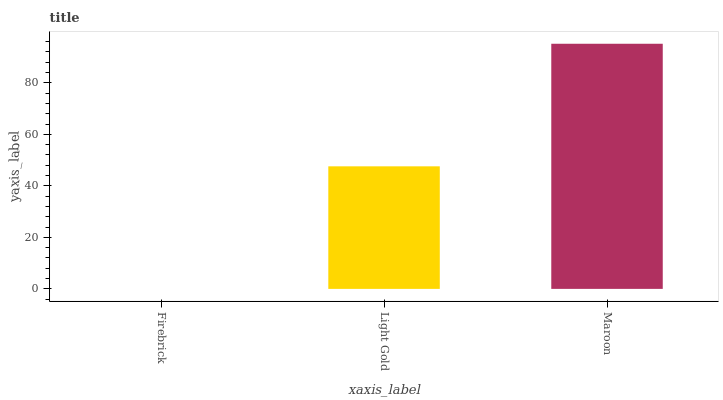Is Light Gold the minimum?
Answer yes or no. No. Is Light Gold the maximum?
Answer yes or no. No. Is Light Gold greater than Firebrick?
Answer yes or no. Yes. Is Firebrick less than Light Gold?
Answer yes or no. Yes. Is Firebrick greater than Light Gold?
Answer yes or no. No. Is Light Gold less than Firebrick?
Answer yes or no. No. Is Light Gold the high median?
Answer yes or no. Yes. Is Light Gold the low median?
Answer yes or no. Yes. Is Maroon the high median?
Answer yes or no. No. Is Maroon the low median?
Answer yes or no. No. 